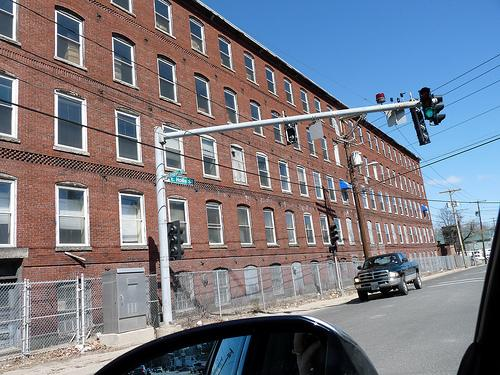What color is the pickup truck and where is it parked? The pickup truck is black and it is parked on a city street. State an accessory that the person in the image is wearing. The person is wearing a ring. How can you describe the building and the material it is made from? The building is tall, long, brown, and made of brick with many windows. What is the shape of the windows mentioned in the captions? The windows are rectangular in shape. What type of fence is on the sidewalk and what does it barricade? There is a chain link fence on the sidewalk, and it barricades the building. Mention an object that can be found on the utility pole in the image. A white transformer can be found on the utility pole. What is the status of the headlights on the truck? The headlights are off on the truck. Describe the position of the truck in relation to other objects in the image. The truck is parked on the street, next to the fence, and near the building. Describe the traffic light and its condition in the image. There is a black traffic light with a green light showing, possibly indicating that it's safe to proceed. 